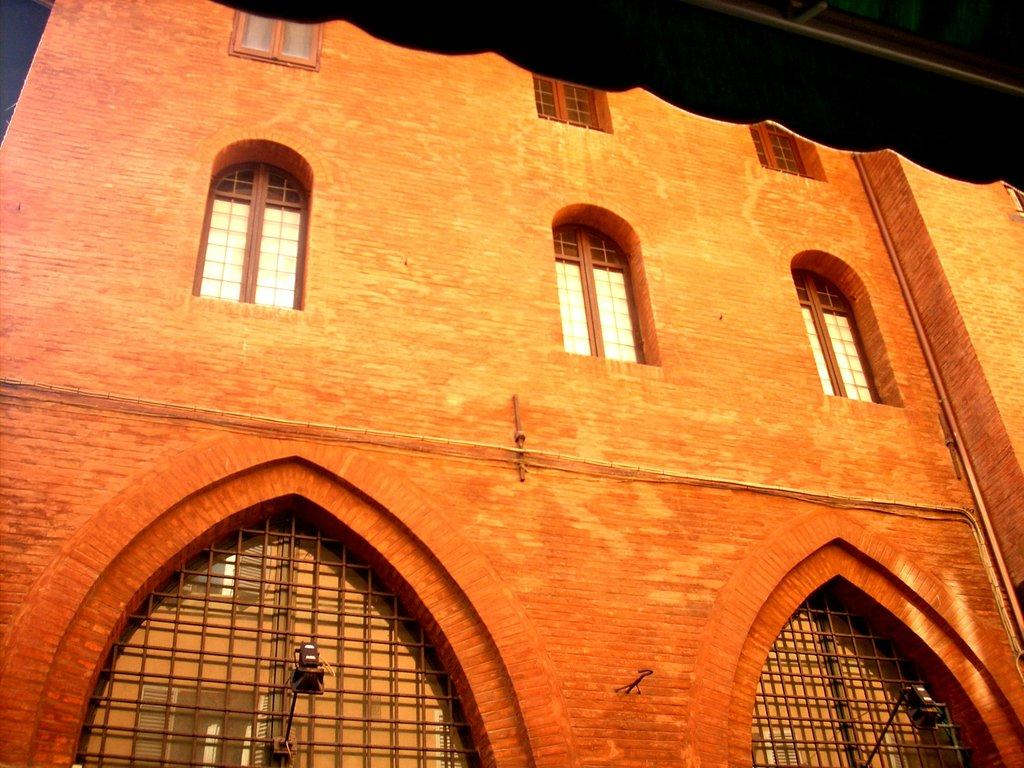What type of structure is present in the image? There is a building in the image. What feature can be observed on the building? The building has glass windows. Are there any other notable features of the building? Yes, the building has lights. What else can be seen in the image besides the building? There are other objects in the image. Can you describe the object located on the right side top of the image? Unfortunately, the provided facts do not give enough information to describe the object on the right side top of the image. How many worms can be seen crawling on the building in the image? There are no worms present in the image. What type of baby is visible in the image? There is no baby present in the image. 